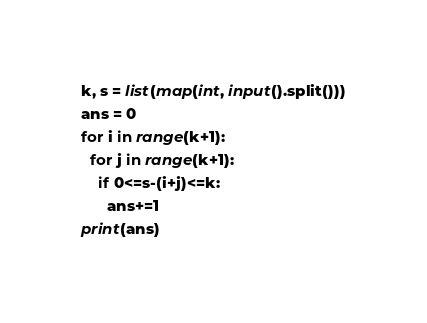Convert code to text. <code><loc_0><loc_0><loc_500><loc_500><_Python_>k, s = list(map(int, input().split()))
ans = 0
for i in range(k+1):
  for j in range(k+1):
    if 0<=s-(i+j)<=k:
      ans+=1
print(ans)</code> 